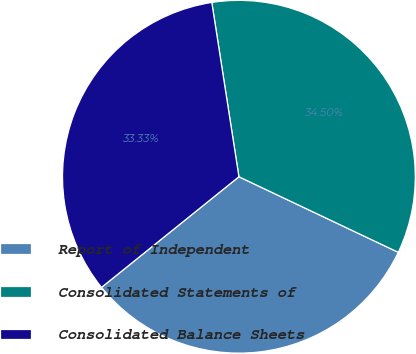<chart> <loc_0><loc_0><loc_500><loc_500><pie_chart><fcel>Report of Independent<fcel>Consolidated Statements of<fcel>Consolidated Balance Sheets<nl><fcel>32.16%<fcel>34.5%<fcel>33.33%<nl></chart> 